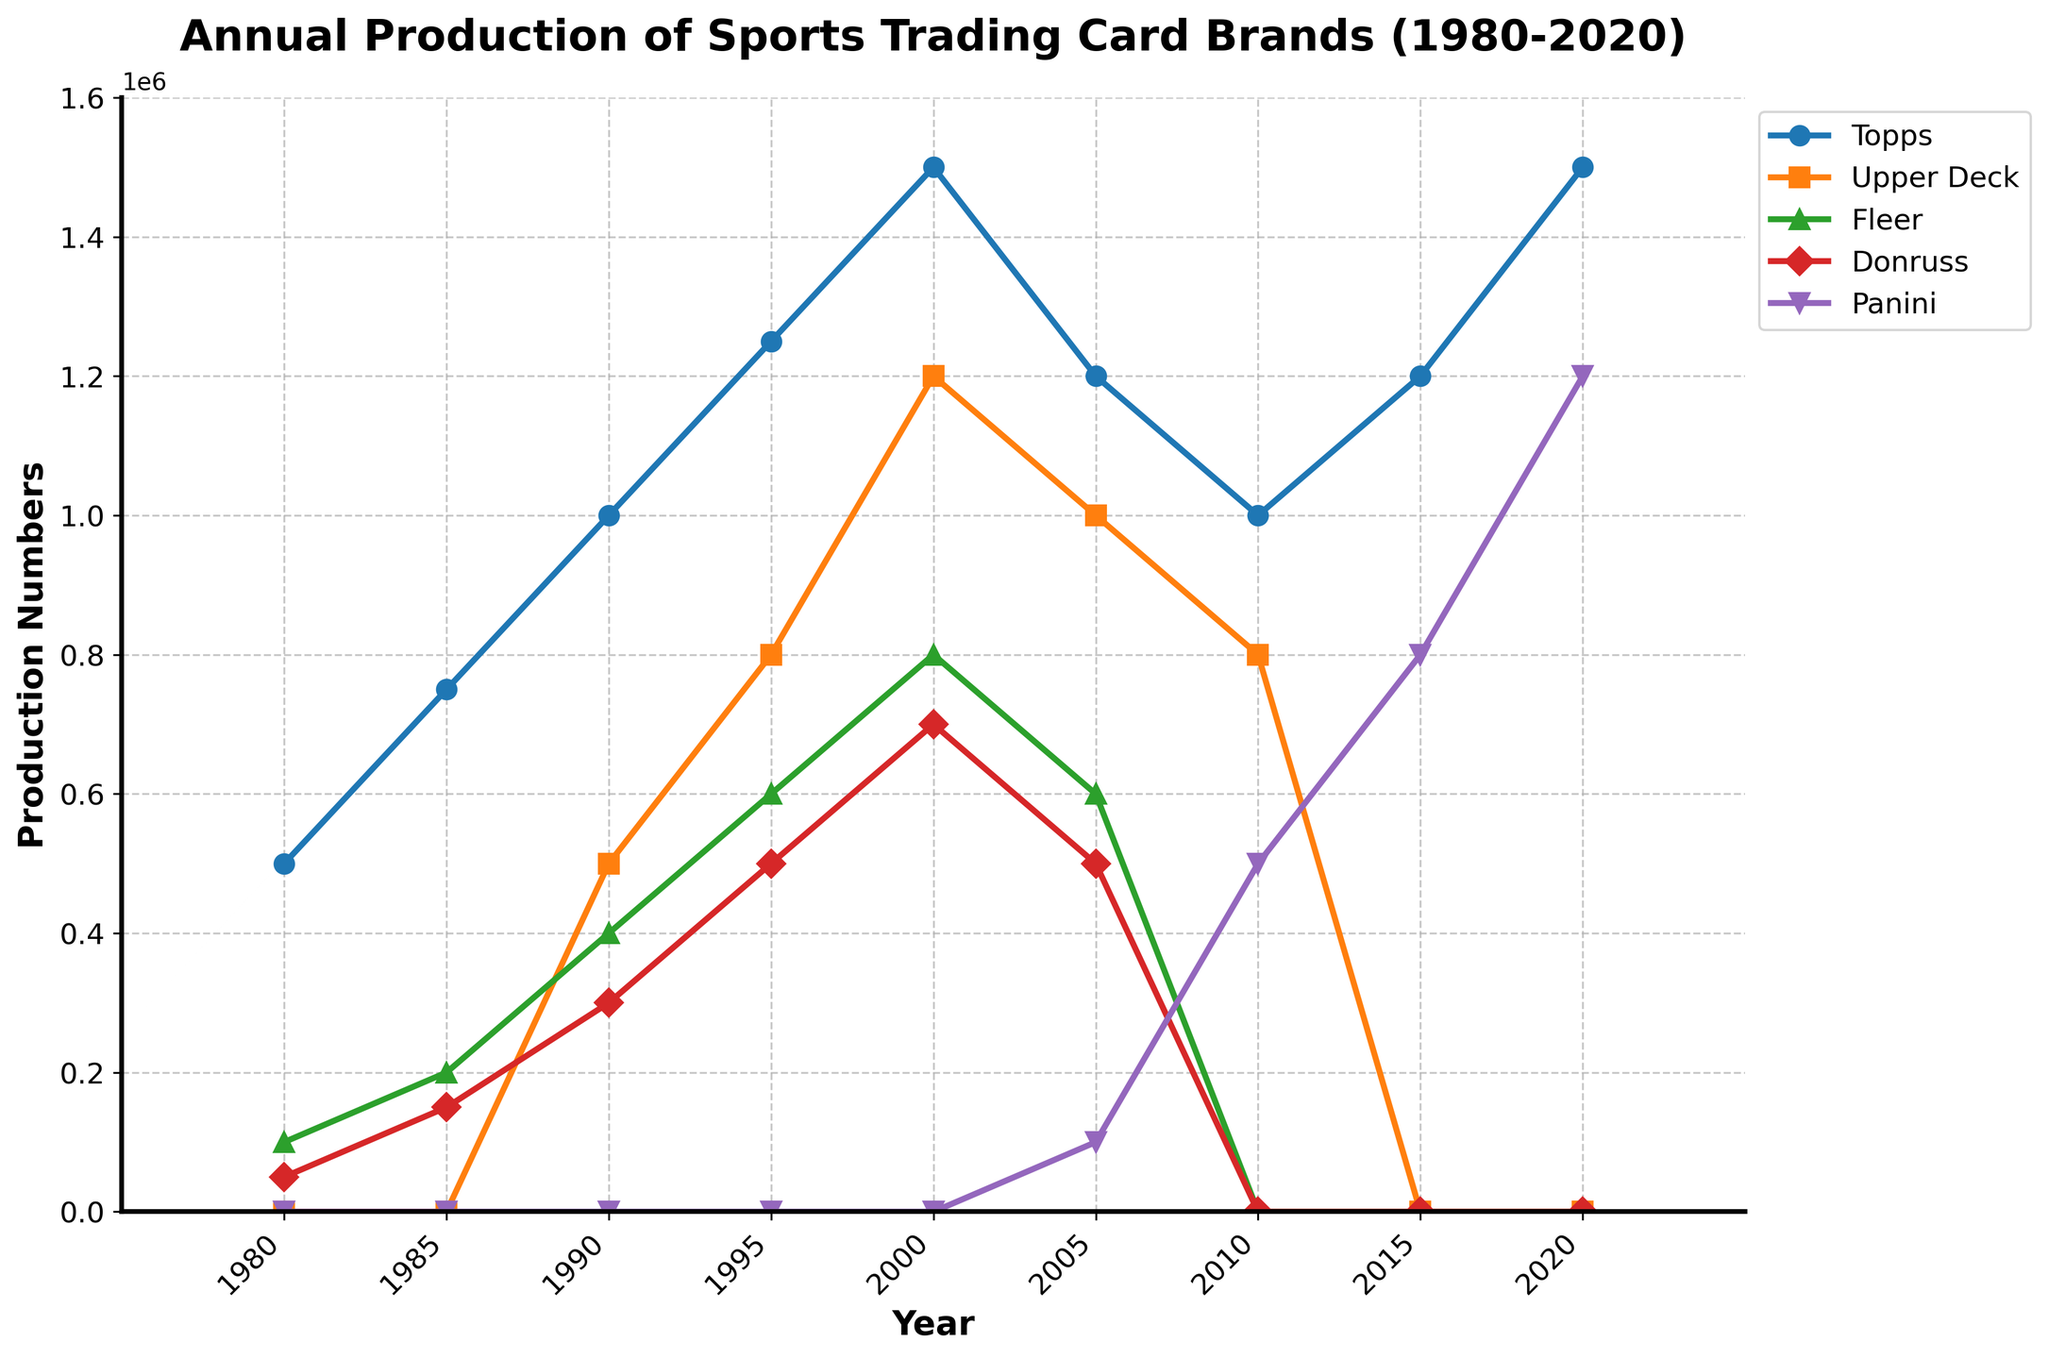What year did Panini first appear in the chart? The figure shows production numbers for Panini starting from 2005.
Answer: 2005 Between 1985 and 1990, which brand saw the largest increase in production numbers? For each brand, subtract the 1985 production numbers from the 1990 numbers: Topps increased by 250,000, Upper Deck had no production in 1985, Fleer increased by 200,000, Donruss increased by 150,000. Therefore, Topps had the largest increase.
Answer: Topps What is the total production for Topps and Upper Deck in 2000? Add the production numbers for Topps and Upper Deck in 2000: 1,500,000 (Topps) + 1,200,000 (Upper Deck) = 2,700,000.
Answer: 2,700,000 Which brand had a production halt between 2010 and 2015? In the plot, Fleer and Donruss both have production equal to 0 during the period from 2010 to 2015. Three brands (Fleer, Donruss, and Upper Deck) show zero production in 2015, but since Fleer and Donruss are missing in both 2010 and 2015, Fleer should be the additional answer.
Answer: Fleer and Donruss When did Donruss have its peak production, and what was the amount? Observe the highest point on the Donruss line. Donruss peaked in 2000 with 700,000 units.
Answer: 2000, 700,000 What was the difference in production numbers for Topps between 2005 and 2010? Subtract the 2010 production number for Topps from the 2005 number: 1,200,000 - 1,000,000 = 200,000.
Answer: 200,000 In 2020, which brand had the second-highest production? The plot shows that in 2020, Panini had the second-highest production number following Topps.
Answer: Panini Compare the production numbers of Fleer and Donruss in 1995. Which brand produced more? The plot shows that in 1995, Fleer produced 600,000, while Donruss produced 500,000. Therefore, Fleer produced more.
Answer: Fleer How did the production number trend for Topps change from 1980 to 2020? Observe the line for Topps from 1980 to 2020. It shows an overall increasing trend from 500,000 in 1980 to 1,500,000 in 2020, with some fluctuations like a temporary drop around 2005 and 2010.
Answer: Increasing, with fluctuations What three brands were produced in 2010? According to the plot, the brands with production numbers in 2010 are Topps, Upper Deck, and Panini.
Answer: Topps, Upper Deck, Panini 